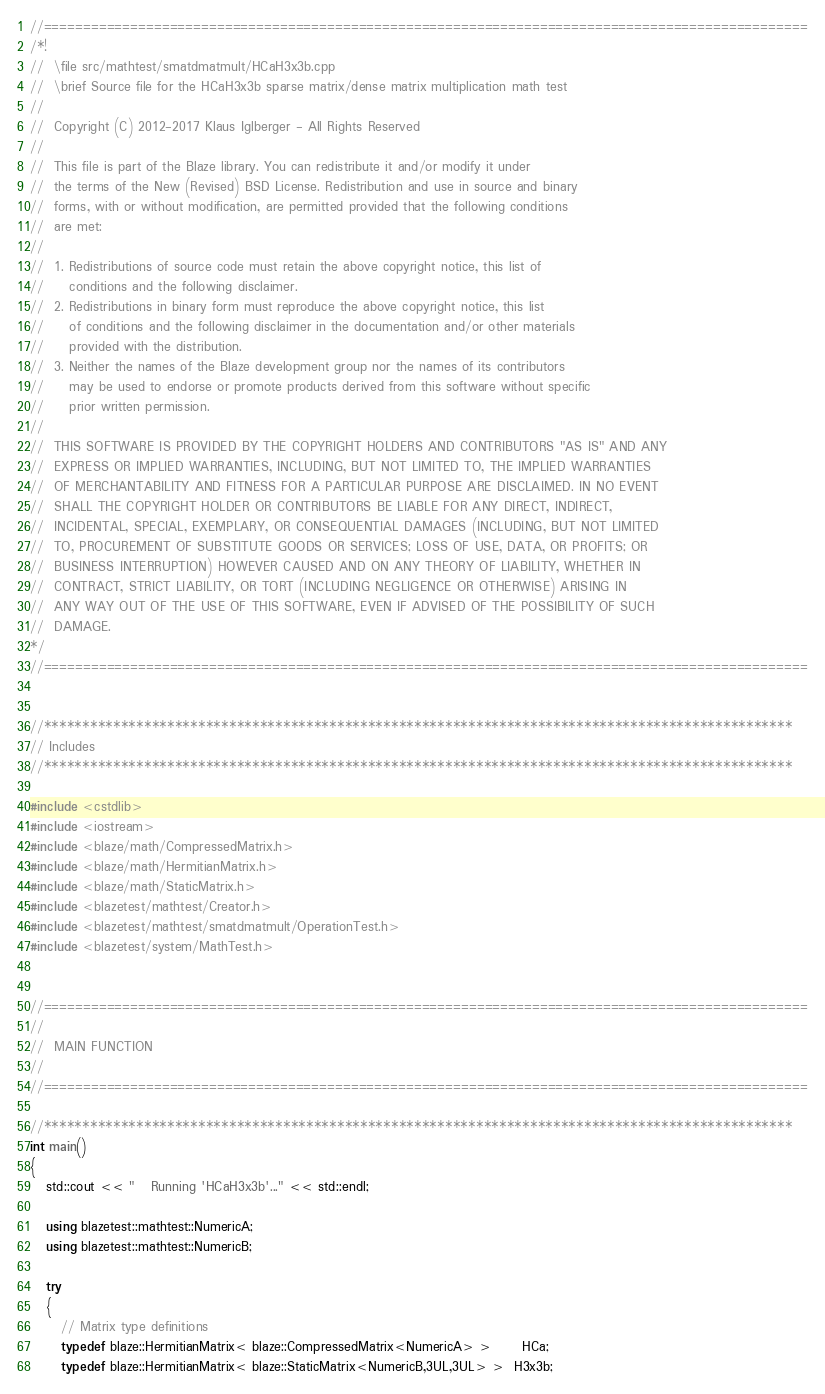Convert code to text. <code><loc_0><loc_0><loc_500><loc_500><_C++_>//=================================================================================================
/*!
//  \file src/mathtest/smatdmatmult/HCaH3x3b.cpp
//  \brief Source file for the HCaH3x3b sparse matrix/dense matrix multiplication math test
//
//  Copyright (C) 2012-2017 Klaus Iglberger - All Rights Reserved
//
//  This file is part of the Blaze library. You can redistribute it and/or modify it under
//  the terms of the New (Revised) BSD License. Redistribution and use in source and binary
//  forms, with or without modification, are permitted provided that the following conditions
//  are met:
//
//  1. Redistributions of source code must retain the above copyright notice, this list of
//     conditions and the following disclaimer.
//  2. Redistributions in binary form must reproduce the above copyright notice, this list
//     of conditions and the following disclaimer in the documentation and/or other materials
//     provided with the distribution.
//  3. Neither the names of the Blaze development group nor the names of its contributors
//     may be used to endorse or promote products derived from this software without specific
//     prior written permission.
//
//  THIS SOFTWARE IS PROVIDED BY THE COPYRIGHT HOLDERS AND CONTRIBUTORS "AS IS" AND ANY
//  EXPRESS OR IMPLIED WARRANTIES, INCLUDING, BUT NOT LIMITED TO, THE IMPLIED WARRANTIES
//  OF MERCHANTABILITY AND FITNESS FOR A PARTICULAR PURPOSE ARE DISCLAIMED. IN NO EVENT
//  SHALL THE COPYRIGHT HOLDER OR CONTRIBUTORS BE LIABLE FOR ANY DIRECT, INDIRECT,
//  INCIDENTAL, SPECIAL, EXEMPLARY, OR CONSEQUENTIAL DAMAGES (INCLUDING, BUT NOT LIMITED
//  TO, PROCUREMENT OF SUBSTITUTE GOODS OR SERVICES; LOSS OF USE, DATA, OR PROFITS; OR
//  BUSINESS INTERRUPTION) HOWEVER CAUSED AND ON ANY THEORY OF LIABILITY, WHETHER IN
//  CONTRACT, STRICT LIABILITY, OR TORT (INCLUDING NEGLIGENCE OR OTHERWISE) ARISING IN
//  ANY WAY OUT OF THE USE OF THIS SOFTWARE, EVEN IF ADVISED OF THE POSSIBILITY OF SUCH
//  DAMAGE.
*/
//=================================================================================================


//*************************************************************************************************
// Includes
//*************************************************************************************************

#include <cstdlib>
#include <iostream>
#include <blaze/math/CompressedMatrix.h>
#include <blaze/math/HermitianMatrix.h>
#include <blaze/math/StaticMatrix.h>
#include <blazetest/mathtest/Creator.h>
#include <blazetest/mathtest/smatdmatmult/OperationTest.h>
#include <blazetest/system/MathTest.h>


//=================================================================================================
//
//  MAIN FUNCTION
//
//=================================================================================================

//*************************************************************************************************
int main()
{
   std::cout << "   Running 'HCaH3x3b'..." << std::endl;

   using blazetest::mathtest::NumericA;
   using blazetest::mathtest::NumericB;

   try
   {
      // Matrix type definitions
      typedef blaze::HermitianMatrix< blaze::CompressedMatrix<NumericA> >      HCa;
      typedef blaze::HermitianMatrix< blaze::StaticMatrix<NumericB,3UL,3UL> >  H3x3b;
</code> 